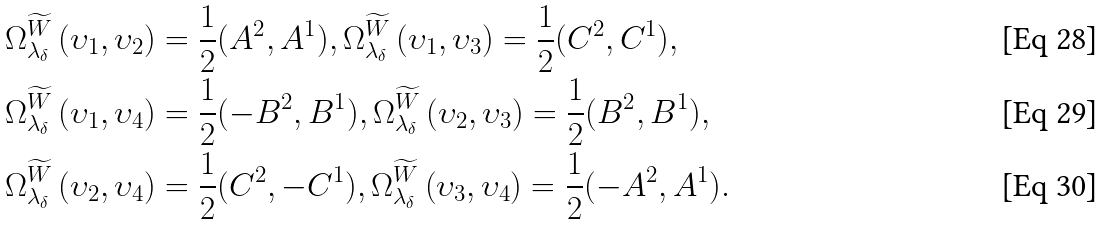Convert formula to latex. <formula><loc_0><loc_0><loc_500><loc_500>\Omega _ { \lambda _ { \delta } } ^ { \widetilde { W } } \left ( \upsilon _ { 1 } , \upsilon _ { 2 } \right ) & = \frac { 1 } { 2 } ( A ^ { 2 } , A ^ { 1 } ) , \Omega _ { \lambda _ { \delta } } ^ { \widetilde { W } } \left ( \upsilon _ { 1 } , \upsilon _ { 3 } \right ) = \frac { 1 } { 2 } ( C ^ { 2 } , C ^ { 1 } ) , \\ \Omega _ { \lambda _ { \delta } } ^ { \widetilde { W } } \left ( \upsilon _ { 1 } , \upsilon _ { 4 } \right ) & = \frac { 1 } { 2 } ( - B ^ { 2 } , B ^ { 1 } ) , \Omega _ { \lambda _ { \delta } } ^ { \widetilde { W } } \left ( \upsilon _ { 2 } , \upsilon _ { 3 } \right ) = \frac { 1 } { 2 } ( B ^ { 2 } , B ^ { 1 } ) , \\ \Omega _ { \lambda _ { \delta } } ^ { \widetilde { W } } \left ( \upsilon _ { 2 } , \upsilon _ { 4 } \right ) & = \frac { 1 } { 2 } ( C ^ { 2 } , - C ^ { 1 } ) , \Omega _ { \lambda _ { \delta } } ^ { \widetilde { W } } \left ( \upsilon _ { 3 } , \upsilon _ { 4 } \right ) = \frac { 1 } { 2 } ( - A ^ { 2 } , A ^ { 1 } ) .</formula> 